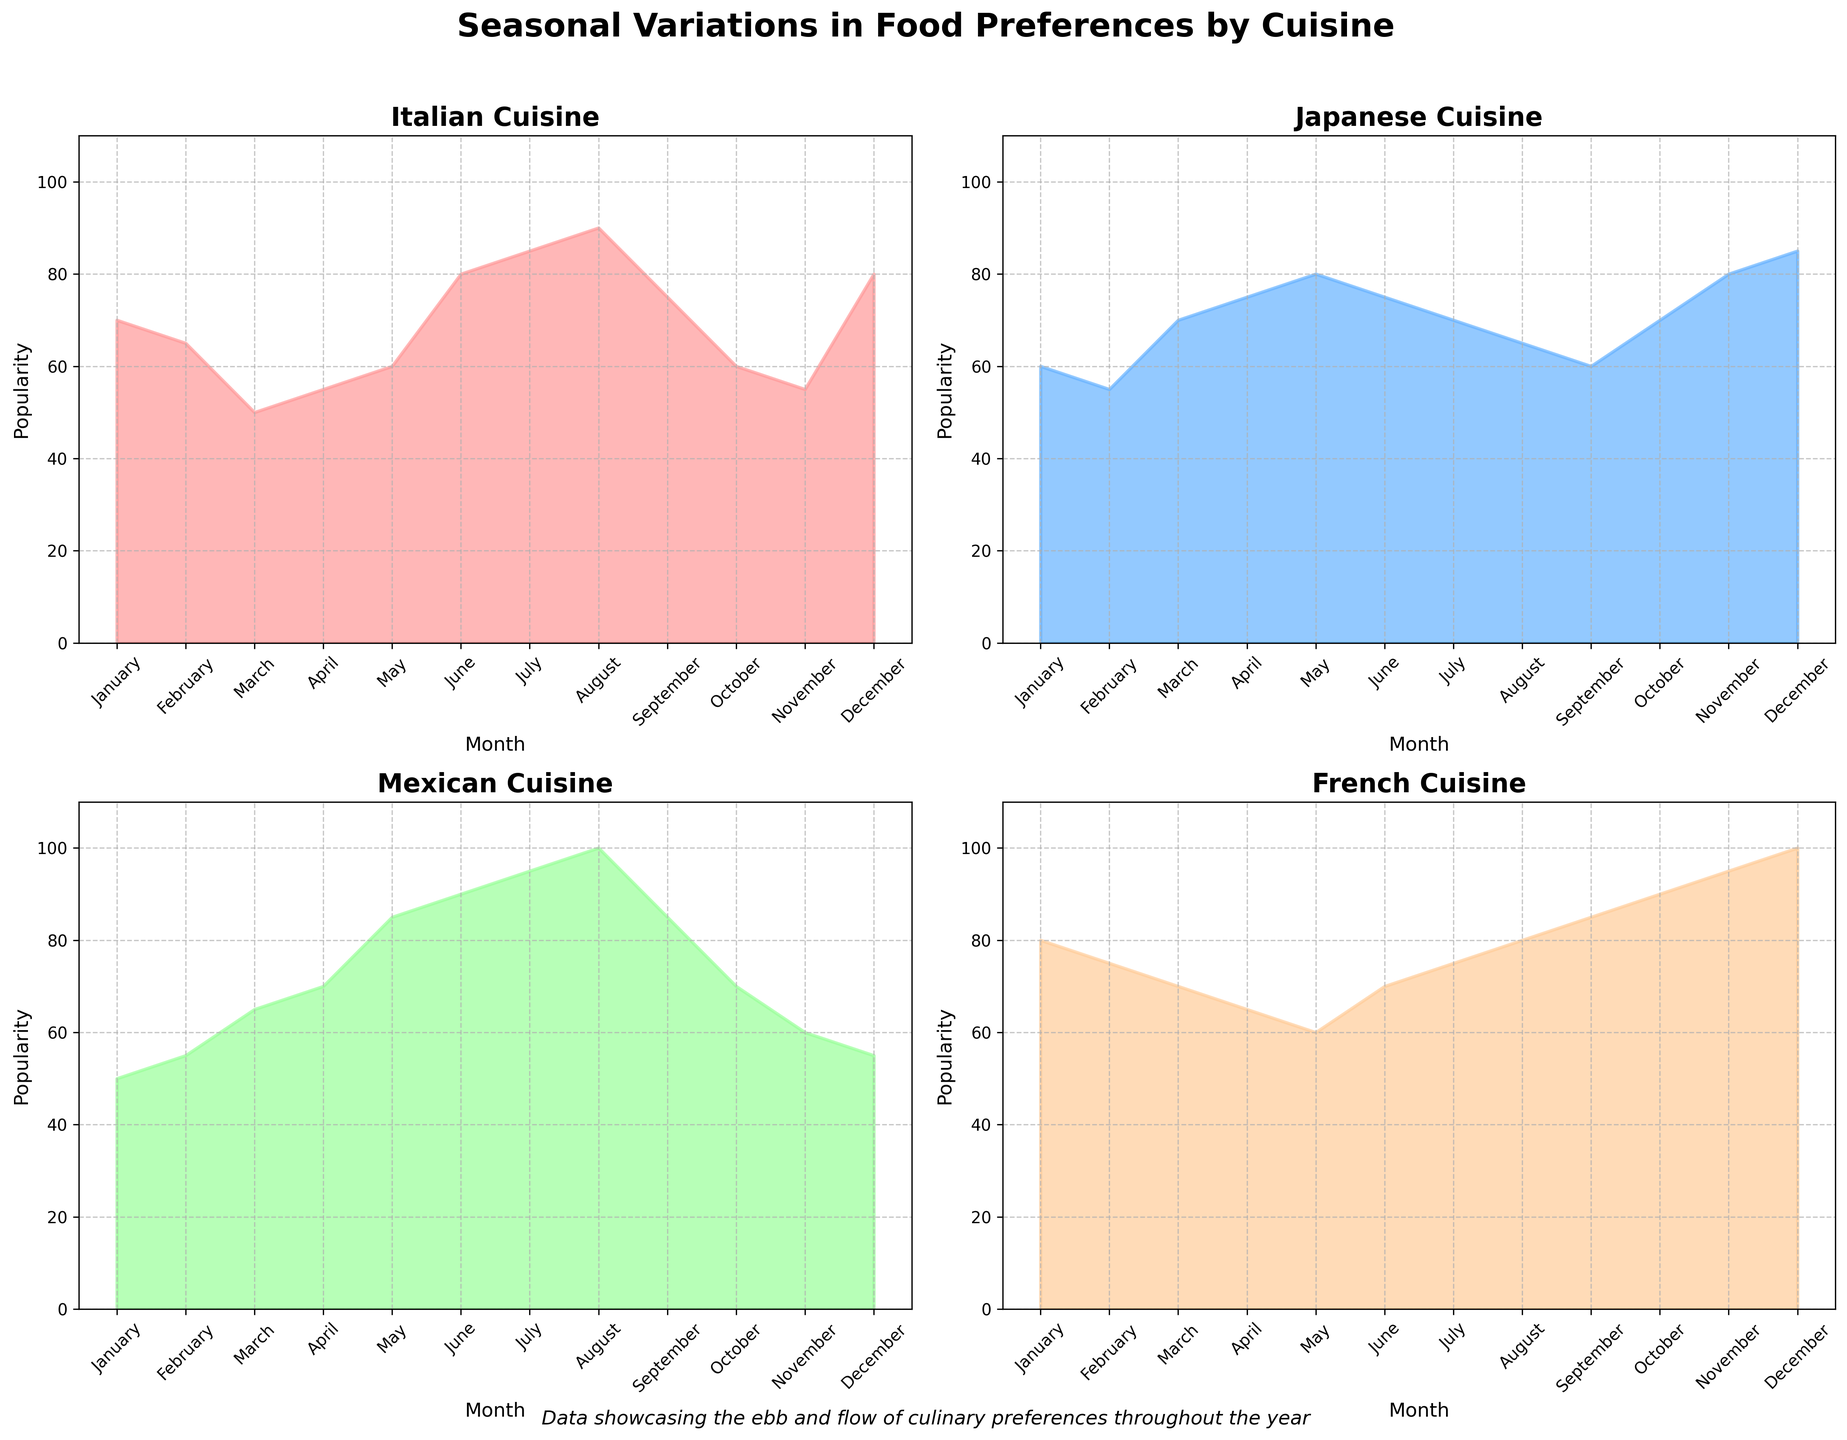What cuisine shows the highest popularity score in the month of December? By looking at the Italian subplot for December, the popularity score is 80. Checking the Japanese subplot, December has a score of 85. For Mexican, the score is 55. French cuisine has the highest score, showing 100 in December. Therefore, French cuisine shows the highest popularity in the month of December.
Answer: French Which month shows the lowest popularity for Japanese cuisine? Refer to the subplot for Japanese cuisine and compare the popularity values for each month. January: 60, February: 55, March: 70, April: 75, May: 80, June: 75, July: 70, August: 65, September: 60, October: 70, November: 80, December: 85. February has the lowest popularity score of 55.
Answer: February What is the trend of Mexican cuisine's popularity from March to September? Look at the points for Mexican cuisine from March to September, the values are increasing: March (65), April (70), May (85), June (90), July (95), August (100), September (85). The trend shows a steady rise reaching the peak in August and then a slight drop in September.
Answer: Increasing trend with a peak in August, followed by a slight drop in September Compare the popularity of Italian and French cuisines in July. Which one is more popular? For Italian cuisine, the popularity in July is 85. For French cuisine, the popularity in July is 75. Thus, Italian cuisine is more popular than French in July.
Answer: Italian During which months does Italian cuisine's popularity increase continuously without any decline? Looking at the Italian subplot: January (70), February (65), March (50), April (55), May (60), June (80), July (85), August (90), September (75), October (60), November (55), December (80). The most continuous increase without any decline occurs from March (50) to August (90).
Answer: March to August What is the average popularity of French cuisine during the first quarter of the year? The first quarter includes January, February, and March. The popularity scores for French cuisine are January: 80, February: 75, March: 70. The sum is 225. The average is 225 / 3 = 75.
Answer: 75 Which cuisine demonstrates a significantly fluctuating pattern in popularity throughout the year? Observing the subplots, Mexican cuisine illustrates a significantly fluctuating pattern with notable peaks in the middle of the year. Popularity rises sharply from March (65) peaking to August (100) and then falls dramatically again.
Answer: Mexican What is the combined popularity score of Japanese cuisine in May and November? Looking at the Japanese subplot, the popularity in May is 80 and November is 80 as well. Adding these scores, 80 + 80 = 160.
Answer: 160 How does the popularity of French cuisine change from October to December? From the subplot of French cuisine, the popularity scores are October: 90, November: 95, December: 100. This shows a consistent increase.
Answer: Increases 